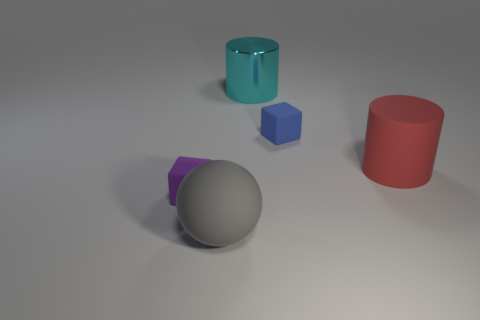Subtract all red cylinders. How many cylinders are left? 1 Subtract 1 blocks. How many blocks are left? 1 Subtract all balls. How many objects are left? 4 Add 1 purple matte objects. How many purple matte objects exist? 2 Add 3 blue rubber things. How many objects exist? 8 Subtract 1 purple blocks. How many objects are left? 4 Subtract all yellow balls. Subtract all red cylinders. How many balls are left? 1 Subtract all yellow balls. How many purple cubes are left? 1 Subtract all large red cylinders. Subtract all small cyan shiny cylinders. How many objects are left? 4 Add 5 tiny things. How many tiny things are left? 7 